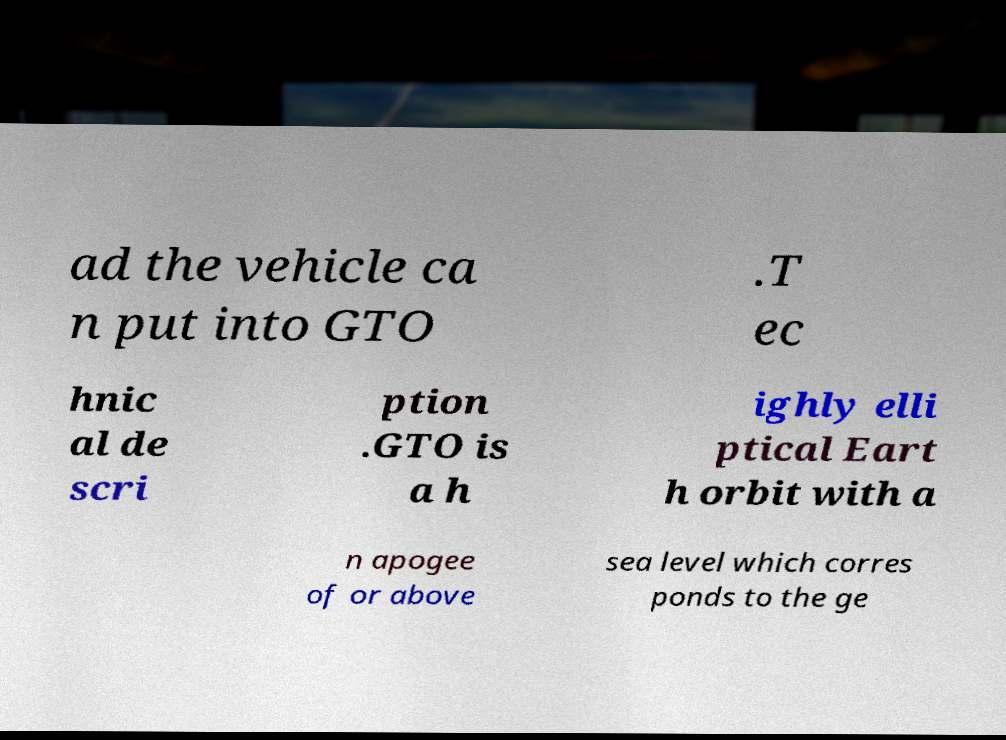There's text embedded in this image that I need extracted. Can you transcribe it verbatim? ad the vehicle ca n put into GTO .T ec hnic al de scri ption .GTO is a h ighly elli ptical Eart h orbit with a n apogee of or above sea level which corres ponds to the ge 